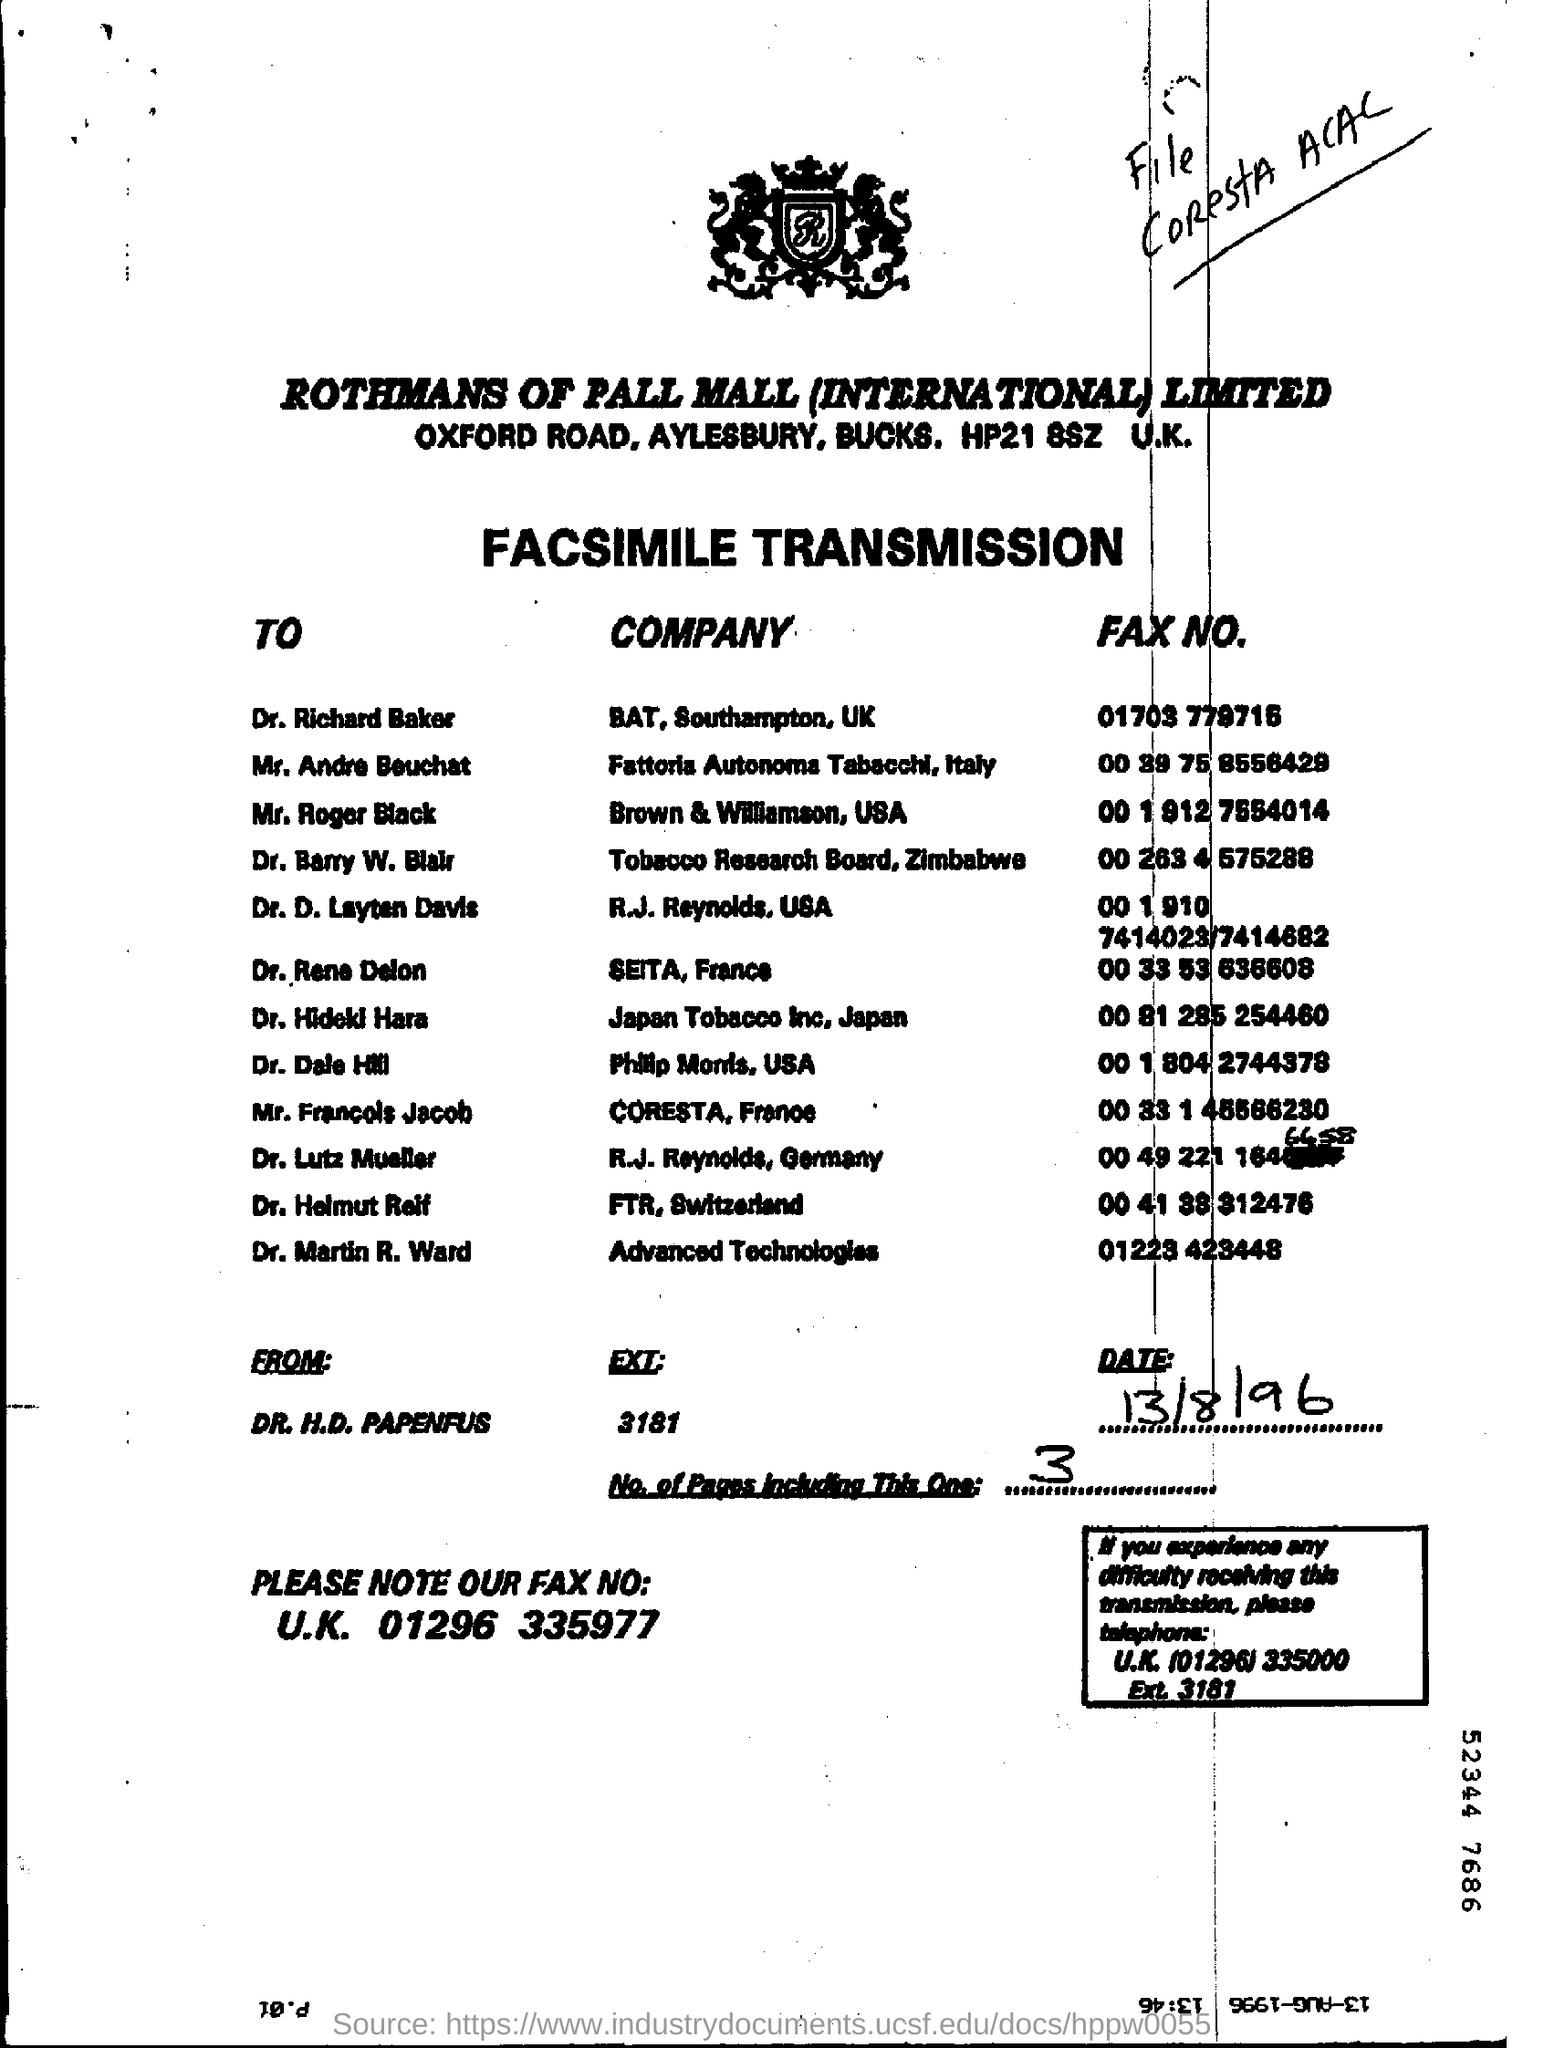What is the date mentioned?
Your response must be concise. 13/8/96. 